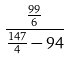<formula> <loc_0><loc_0><loc_500><loc_500>\frac { \frac { 9 9 } { 6 } } { \frac { 1 4 7 } { 4 } - 9 4 }</formula> 